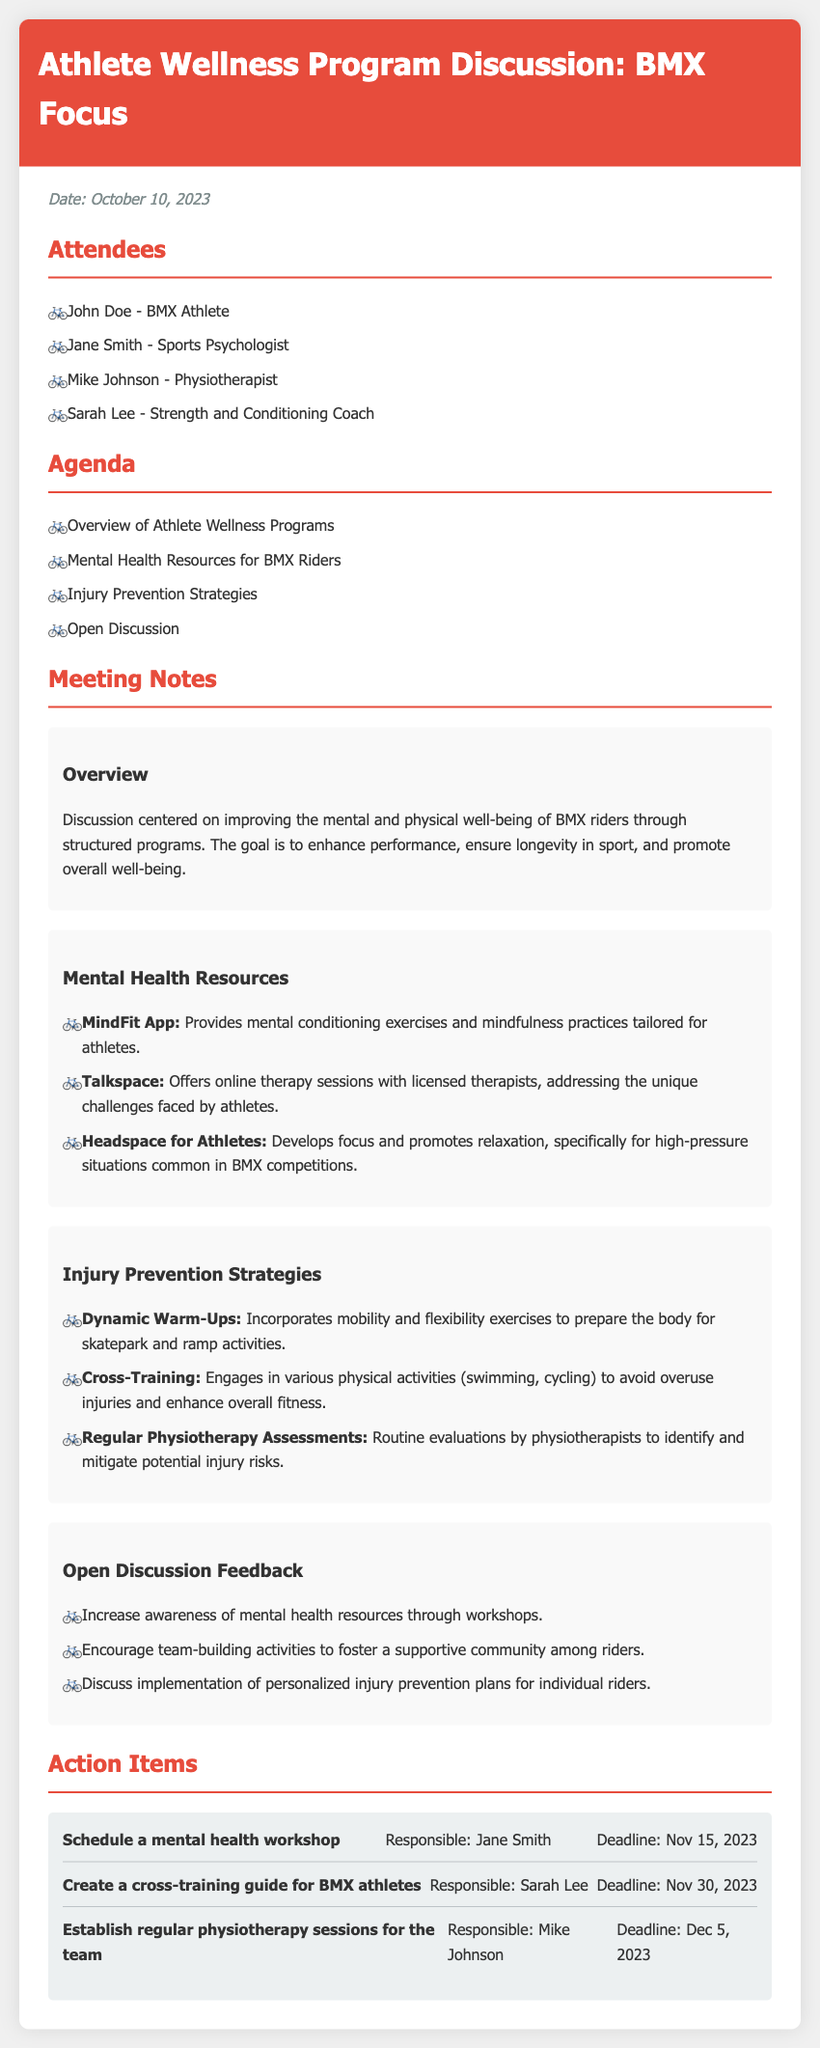What is the date of the meeting? The date of the meeting is explicitly mentioned at the start of the document, which is October 10, 2023.
Answer: October 10, 2023 Who is the sports psychologist mentioned in the minutes? The sports psychologist is listed among the attendees of the meeting, which is Jane Smith.
Answer: Jane Smith What is one of the mental health resources for BMX riders? The document lists various mental health resources under the "Mental Health Resources" section, one of which is the MindFit App.
Answer: MindFit App What injury prevention strategy involves exercises to prepare the body? The minutes specify that "Dynamic Warm-Ups" incorporate mobility and flexibility exercises to prepare the body.
Answer: Dynamic Warm-Ups Who is responsible for scheduling a mental health workshop? The action items section states that Jane Smith is responsible for this task.
Answer: Jane Smith What is one proposed action item regarding physiotherapy? The document outlines the establishment of regular physiotherapy sessions as an action item, detailing responsible persons and deadlines.
Answer: Establish regular physiotherapy sessions for the team Why should awareness of mental health resources be increased? The feedback notes suggest this as a way to improve support for BMX riders, highlighting the importance of community and resources.
Answer: Workshops What is the main goal discussed in the overview of the meeting? The goal discussed in the overview focuses on improving the well-being of BMX riders.
Answer: Improve well-being 